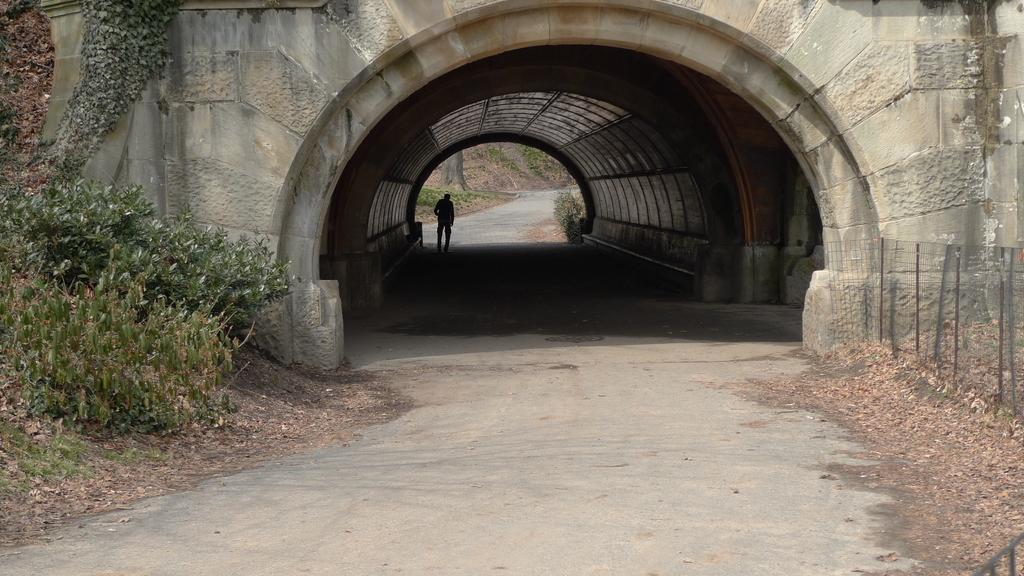What type of living organisms can be seen in the image? Plants can be seen in the image. What type of structure is present in the image? There is a fence and a tunnel in the image. Can you describe the person in the image? There is a person standing in the background of the image. What other natural elements can be seen in the background of the image? There is a plant and a tree trunk visible in the background of the image. What time does the clock show in the image? There is no clock present in the image. What type of stew is being prepared in the background of the image? There is no stew or cooking activity visible in the image. 